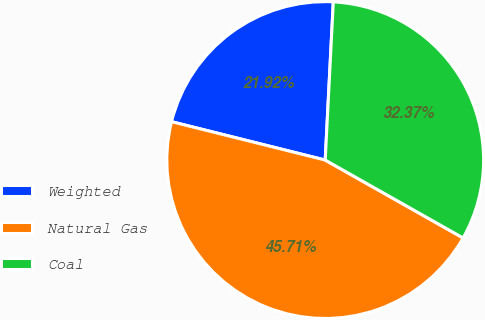Convert chart to OTSL. <chart><loc_0><loc_0><loc_500><loc_500><pie_chart><fcel>Weighted<fcel>Natural Gas<fcel>Coal<nl><fcel>21.92%<fcel>45.71%<fcel>32.37%<nl></chart> 